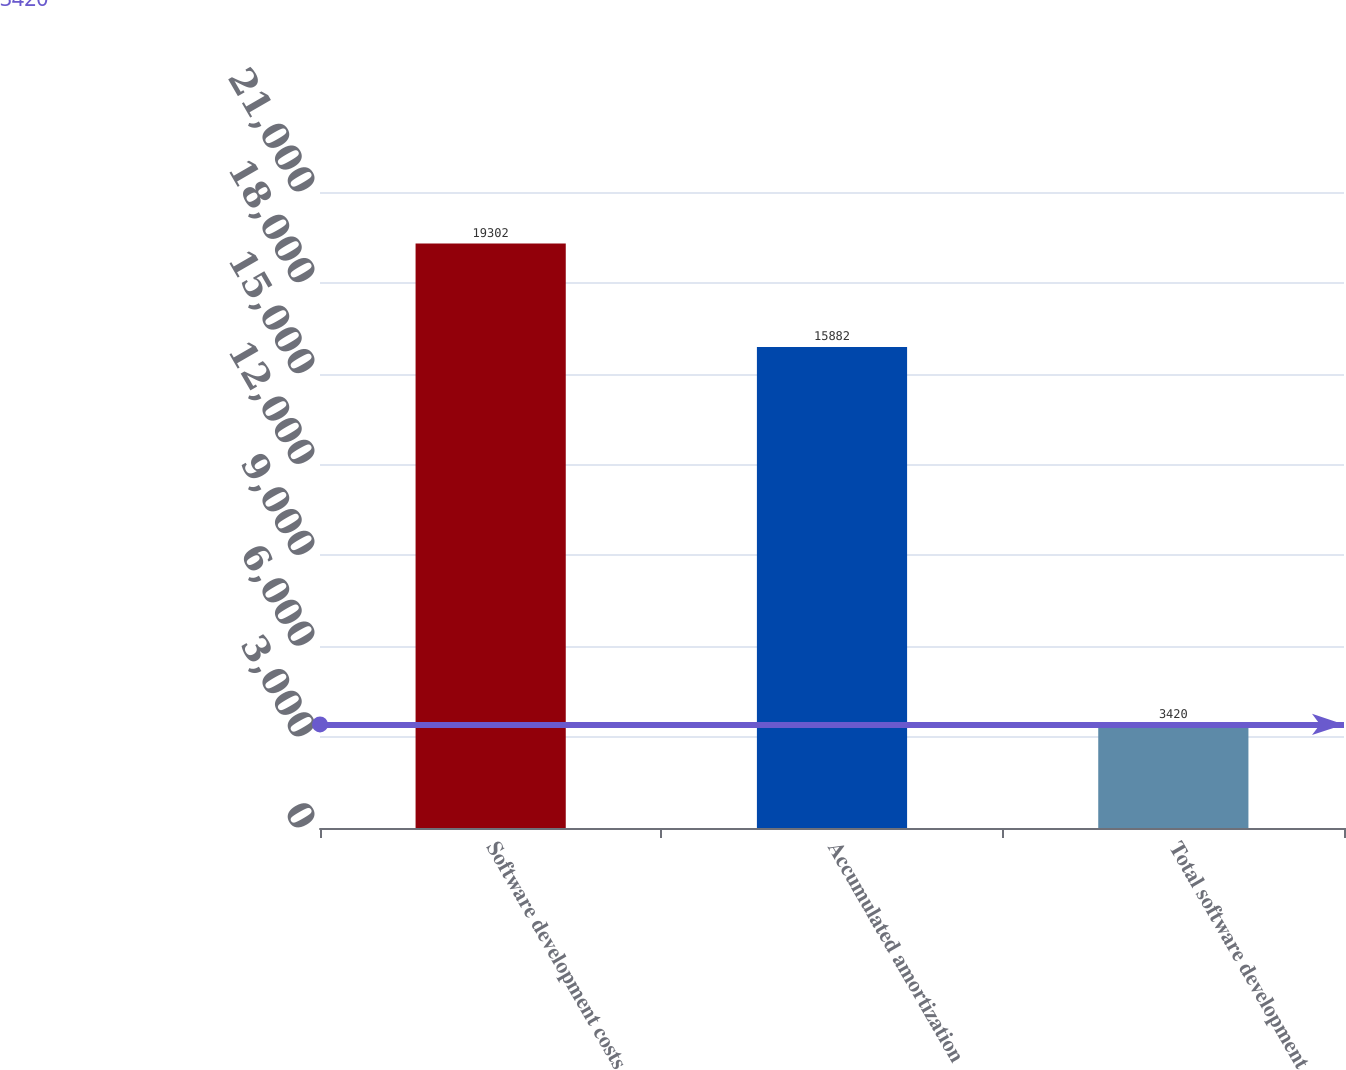Convert chart to OTSL. <chart><loc_0><loc_0><loc_500><loc_500><bar_chart><fcel>Software development costs<fcel>Accumulated amortization<fcel>Total software development<nl><fcel>19302<fcel>15882<fcel>3420<nl></chart> 